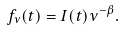Convert formula to latex. <formula><loc_0><loc_0><loc_500><loc_500>f _ { \nu } ( t ) = I ( t ) \nu ^ { - \beta } .</formula> 